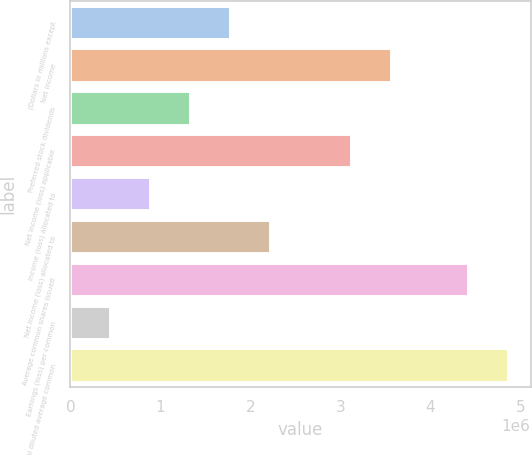Convert chart. <chart><loc_0><loc_0><loc_500><loc_500><bar_chart><fcel>(Dollars in millions except<fcel>Net income<fcel>Preferred stock dividends<fcel>Net income (loss) applicable<fcel>Income (loss) allocated to<fcel>Net income (loss) allocated to<fcel>Average common shares issued<fcel>Earnings (loss) per common<fcel>Total diluted average common<nl><fcel>1.78529e+06<fcel>3.57057e+06<fcel>1.33897e+06<fcel>3.12425e+06<fcel>892645<fcel>2.23161e+06<fcel>4.42358e+06<fcel>446324<fcel>4.8699e+06<nl></chart> 